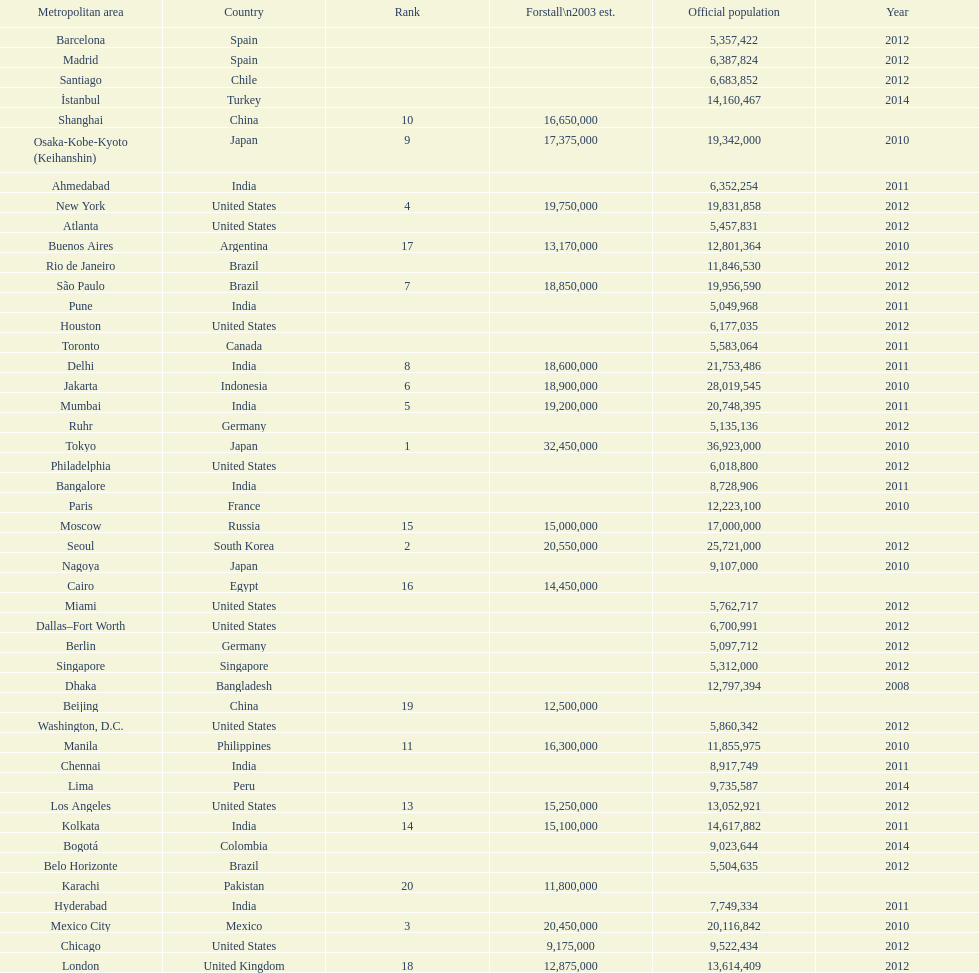Which population is listed before 5,357,422? 8,728,906. 